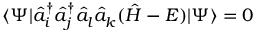<formula> <loc_0><loc_0><loc_500><loc_500>\langle \Psi | \hat { a } _ { i } ^ { \dagger } \hat { a } _ { j } ^ { \dagger } \hat { a } _ { l } \hat { a } _ { k } ( \hat { H } - E ) | \Psi \rangle = 0</formula> 